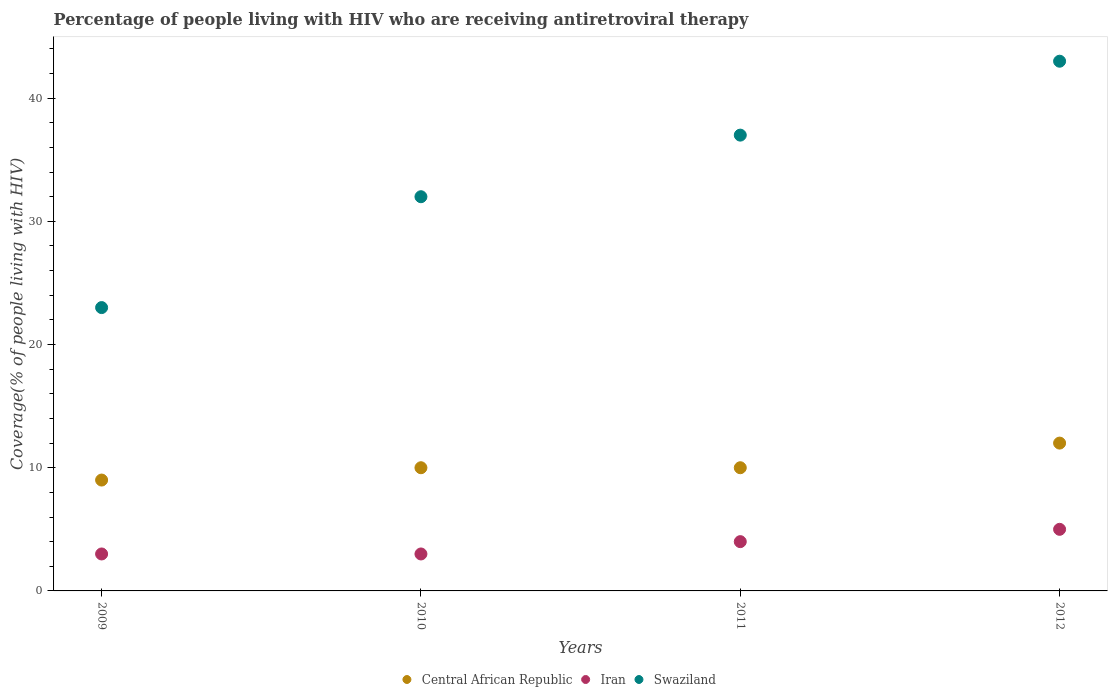How many different coloured dotlines are there?
Ensure brevity in your answer.  3. Is the number of dotlines equal to the number of legend labels?
Offer a terse response. Yes. What is the percentage of the HIV infected people who are receiving antiretroviral therapy in Iran in 2012?
Provide a succinct answer. 5. Across all years, what is the maximum percentage of the HIV infected people who are receiving antiretroviral therapy in Swaziland?
Offer a terse response. 43. Across all years, what is the minimum percentage of the HIV infected people who are receiving antiretroviral therapy in Central African Republic?
Your response must be concise. 9. What is the total percentage of the HIV infected people who are receiving antiretroviral therapy in Iran in the graph?
Your answer should be very brief. 15. What is the difference between the percentage of the HIV infected people who are receiving antiretroviral therapy in Central African Republic in 2009 and that in 2010?
Provide a succinct answer. -1. What is the difference between the percentage of the HIV infected people who are receiving antiretroviral therapy in Central African Republic in 2011 and the percentage of the HIV infected people who are receiving antiretroviral therapy in Iran in 2012?
Offer a terse response. 5. What is the average percentage of the HIV infected people who are receiving antiretroviral therapy in Swaziland per year?
Make the answer very short. 33.75. In the year 2010, what is the difference between the percentage of the HIV infected people who are receiving antiretroviral therapy in Swaziland and percentage of the HIV infected people who are receiving antiretroviral therapy in Central African Republic?
Offer a very short reply. 22. Is the percentage of the HIV infected people who are receiving antiretroviral therapy in Swaziland in 2009 less than that in 2011?
Offer a very short reply. Yes. Is the difference between the percentage of the HIV infected people who are receiving antiretroviral therapy in Swaziland in 2010 and 2012 greater than the difference between the percentage of the HIV infected people who are receiving antiretroviral therapy in Central African Republic in 2010 and 2012?
Offer a terse response. No. What is the difference between the highest and the lowest percentage of the HIV infected people who are receiving antiretroviral therapy in Central African Republic?
Make the answer very short. 3. Is it the case that in every year, the sum of the percentage of the HIV infected people who are receiving antiretroviral therapy in Swaziland and percentage of the HIV infected people who are receiving antiretroviral therapy in Iran  is greater than the percentage of the HIV infected people who are receiving antiretroviral therapy in Central African Republic?
Keep it short and to the point. Yes. Is the percentage of the HIV infected people who are receiving antiretroviral therapy in Swaziland strictly greater than the percentage of the HIV infected people who are receiving antiretroviral therapy in Iran over the years?
Provide a short and direct response. Yes. Is the percentage of the HIV infected people who are receiving antiretroviral therapy in Central African Republic strictly less than the percentage of the HIV infected people who are receiving antiretroviral therapy in Iran over the years?
Offer a very short reply. No. How many dotlines are there?
Offer a very short reply. 3. What is the difference between two consecutive major ticks on the Y-axis?
Keep it short and to the point. 10. Does the graph contain any zero values?
Provide a succinct answer. No. Where does the legend appear in the graph?
Provide a short and direct response. Bottom center. What is the title of the graph?
Provide a short and direct response. Percentage of people living with HIV who are receiving antiretroviral therapy. What is the label or title of the X-axis?
Make the answer very short. Years. What is the label or title of the Y-axis?
Keep it short and to the point. Coverage(% of people living with HIV). What is the Coverage(% of people living with HIV) in Swaziland in 2009?
Offer a terse response. 23. What is the Coverage(% of people living with HIV) of Central African Republic in 2010?
Keep it short and to the point. 10. What is the Coverage(% of people living with HIV) in Central African Republic in 2012?
Ensure brevity in your answer.  12. Across all years, what is the maximum Coverage(% of people living with HIV) of Swaziland?
Offer a terse response. 43. Across all years, what is the minimum Coverage(% of people living with HIV) in Iran?
Give a very brief answer. 3. Across all years, what is the minimum Coverage(% of people living with HIV) of Swaziland?
Provide a short and direct response. 23. What is the total Coverage(% of people living with HIV) of Central African Republic in the graph?
Provide a short and direct response. 41. What is the total Coverage(% of people living with HIV) in Iran in the graph?
Your answer should be very brief. 15. What is the total Coverage(% of people living with HIV) in Swaziland in the graph?
Offer a terse response. 135. What is the difference between the Coverage(% of people living with HIV) of Central African Republic in 2009 and that in 2011?
Keep it short and to the point. -1. What is the difference between the Coverage(% of people living with HIV) of Swaziland in 2009 and that in 2011?
Provide a short and direct response. -14. What is the difference between the Coverage(% of people living with HIV) of Iran in 2009 and that in 2012?
Provide a succinct answer. -2. What is the difference between the Coverage(% of people living with HIV) of Central African Republic in 2010 and that in 2011?
Offer a terse response. 0. What is the difference between the Coverage(% of people living with HIV) in Swaziland in 2010 and that in 2012?
Provide a short and direct response. -11. What is the difference between the Coverage(% of people living with HIV) of Central African Republic in 2011 and that in 2012?
Your response must be concise. -2. What is the difference between the Coverage(% of people living with HIV) of Iran in 2011 and that in 2012?
Keep it short and to the point. -1. What is the difference between the Coverage(% of people living with HIV) of Central African Republic in 2009 and the Coverage(% of people living with HIV) of Swaziland in 2010?
Your answer should be compact. -23. What is the difference between the Coverage(% of people living with HIV) in Central African Republic in 2009 and the Coverage(% of people living with HIV) in Iran in 2011?
Offer a terse response. 5. What is the difference between the Coverage(% of people living with HIV) of Iran in 2009 and the Coverage(% of people living with HIV) of Swaziland in 2011?
Offer a very short reply. -34. What is the difference between the Coverage(% of people living with HIV) of Central African Republic in 2009 and the Coverage(% of people living with HIV) of Iran in 2012?
Offer a terse response. 4. What is the difference between the Coverage(% of people living with HIV) of Central African Republic in 2009 and the Coverage(% of people living with HIV) of Swaziland in 2012?
Offer a very short reply. -34. What is the difference between the Coverage(% of people living with HIV) in Iran in 2009 and the Coverage(% of people living with HIV) in Swaziland in 2012?
Your answer should be very brief. -40. What is the difference between the Coverage(% of people living with HIV) of Central African Republic in 2010 and the Coverage(% of people living with HIV) of Iran in 2011?
Offer a very short reply. 6. What is the difference between the Coverage(% of people living with HIV) in Iran in 2010 and the Coverage(% of people living with HIV) in Swaziland in 2011?
Offer a terse response. -34. What is the difference between the Coverage(% of people living with HIV) in Central African Republic in 2010 and the Coverage(% of people living with HIV) in Iran in 2012?
Your answer should be compact. 5. What is the difference between the Coverage(% of people living with HIV) of Central African Republic in 2010 and the Coverage(% of people living with HIV) of Swaziland in 2012?
Your answer should be compact. -33. What is the difference between the Coverage(% of people living with HIV) in Iran in 2010 and the Coverage(% of people living with HIV) in Swaziland in 2012?
Offer a very short reply. -40. What is the difference between the Coverage(% of people living with HIV) in Central African Republic in 2011 and the Coverage(% of people living with HIV) in Iran in 2012?
Ensure brevity in your answer.  5. What is the difference between the Coverage(% of people living with HIV) in Central African Republic in 2011 and the Coverage(% of people living with HIV) in Swaziland in 2012?
Provide a short and direct response. -33. What is the difference between the Coverage(% of people living with HIV) of Iran in 2011 and the Coverage(% of people living with HIV) of Swaziland in 2012?
Your response must be concise. -39. What is the average Coverage(% of people living with HIV) in Central African Republic per year?
Provide a short and direct response. 10.25. What is the average Coverage(% of people living with HIV) of Iran per year?
Offer a very short reply. 3.75. What is the average Coverage(% of people living with HIV) in Swaziland per year?
Ensure brevity in your answer.  33.75. In the year 2009, what is the difference between the Coverage(% of people living with HIV) in Iran and Coverage(% of people living with HIV) in Swaziland?
Ensure brevity in your answer.  -20. In the year 2010, what is the difference between the Coverage(% of people living with HIV) in Central African Republic and Coverage(% of people living with HIV) in Iran?
Provide a short and direct response. 7. In the year 2011, what is the difference between the Coverage(% of people living with HIV) in Central African Republic and Coverage(% of people living with HIV) in Iran?
Give a very brief answer. 6. In the year 2011, what is the difference between the Coverage(% of people living with HIV) of Iran and Coverage(% of people living with HIV) of Swaziland?
Provide a succinct answer. -33. In the year 2012, what is the difference between the Coverage(% of people living with HIV) of Central African Republic and Coverage(% of people living with HIV) of Iran?
Give a very brief answer. 7. In the year 2012, what is the difference between the Coverage(% of people living with HIV) in Central African Republic and Coverage(% of people living with HIV) in Swaziland?
Make the answer very short. -31. In the year 2012, what is the difference between the Coverage(% of people living with HIV) of Iran and Coverage(% of people living with HIV) of Swaziland?
Keep it short and to the point. -38. What is the ratio of the Coverage(% of people living with HIV) of Central African Republic in 2009 to that in 2010?
Your response must be concise. 0.9. What is the ratio of the Coverage(% of people living with HIV) in Iran in 2009 to that in 2010?
Offer a terse response. 1. What is the ratio of the Coverage(% of people living with HIV) of Swaziland in 2009 to that in 2010?
Offer a very short reply. 0.72. What is the ratio of the Coverage(% of people living with HIV) of Swaziland in 2009 to that in 2011?
Keep it short and to the point. 0.62. What is the ratio of the Coverage(% of people living with HIV) in Iran in 2009 to that in 2012?
Offer a very short reply. 0.6. What is the ratio of the Coverage(% of people living with HIV) of Swaziland in 2009 to that in 2012?
Provide a short and direct response. 0.53. What is the ratio of the Coverage(% of people living with HIV) of Iran in 2010 to that in 2011?
Give a very brief answer. 0.75. What is the ratio of the Coverage(% of people living with HIV) of Swaziland in 2010 to that in 2011?
Your response must be concise. 0.86. What is the ratio of the Coverage(% of people living with HIV) of Swaziland in 2010 to that in 2012?
Offer a terse response. 0.74. What is the ratio of the Coverage(% of people living with HIV) of Central African Republic in 2011 to that in 2012?
Your answer should be very brief. 0.83. What is the ratio of the Coverage(% of people living with HIV) of Swaziland in 2011 to that in 2012?
Your response must be concise. 0.86. What is the difference between the highest and the second highest Coverage(% of people living with HIV) of Central African Republic?
Ensure brevity in your answer.  2. What is the difference between the highest and the lowest Coverage(% of people living with HIV) of Central African Republic?
Keep it short and to the point. 3. 